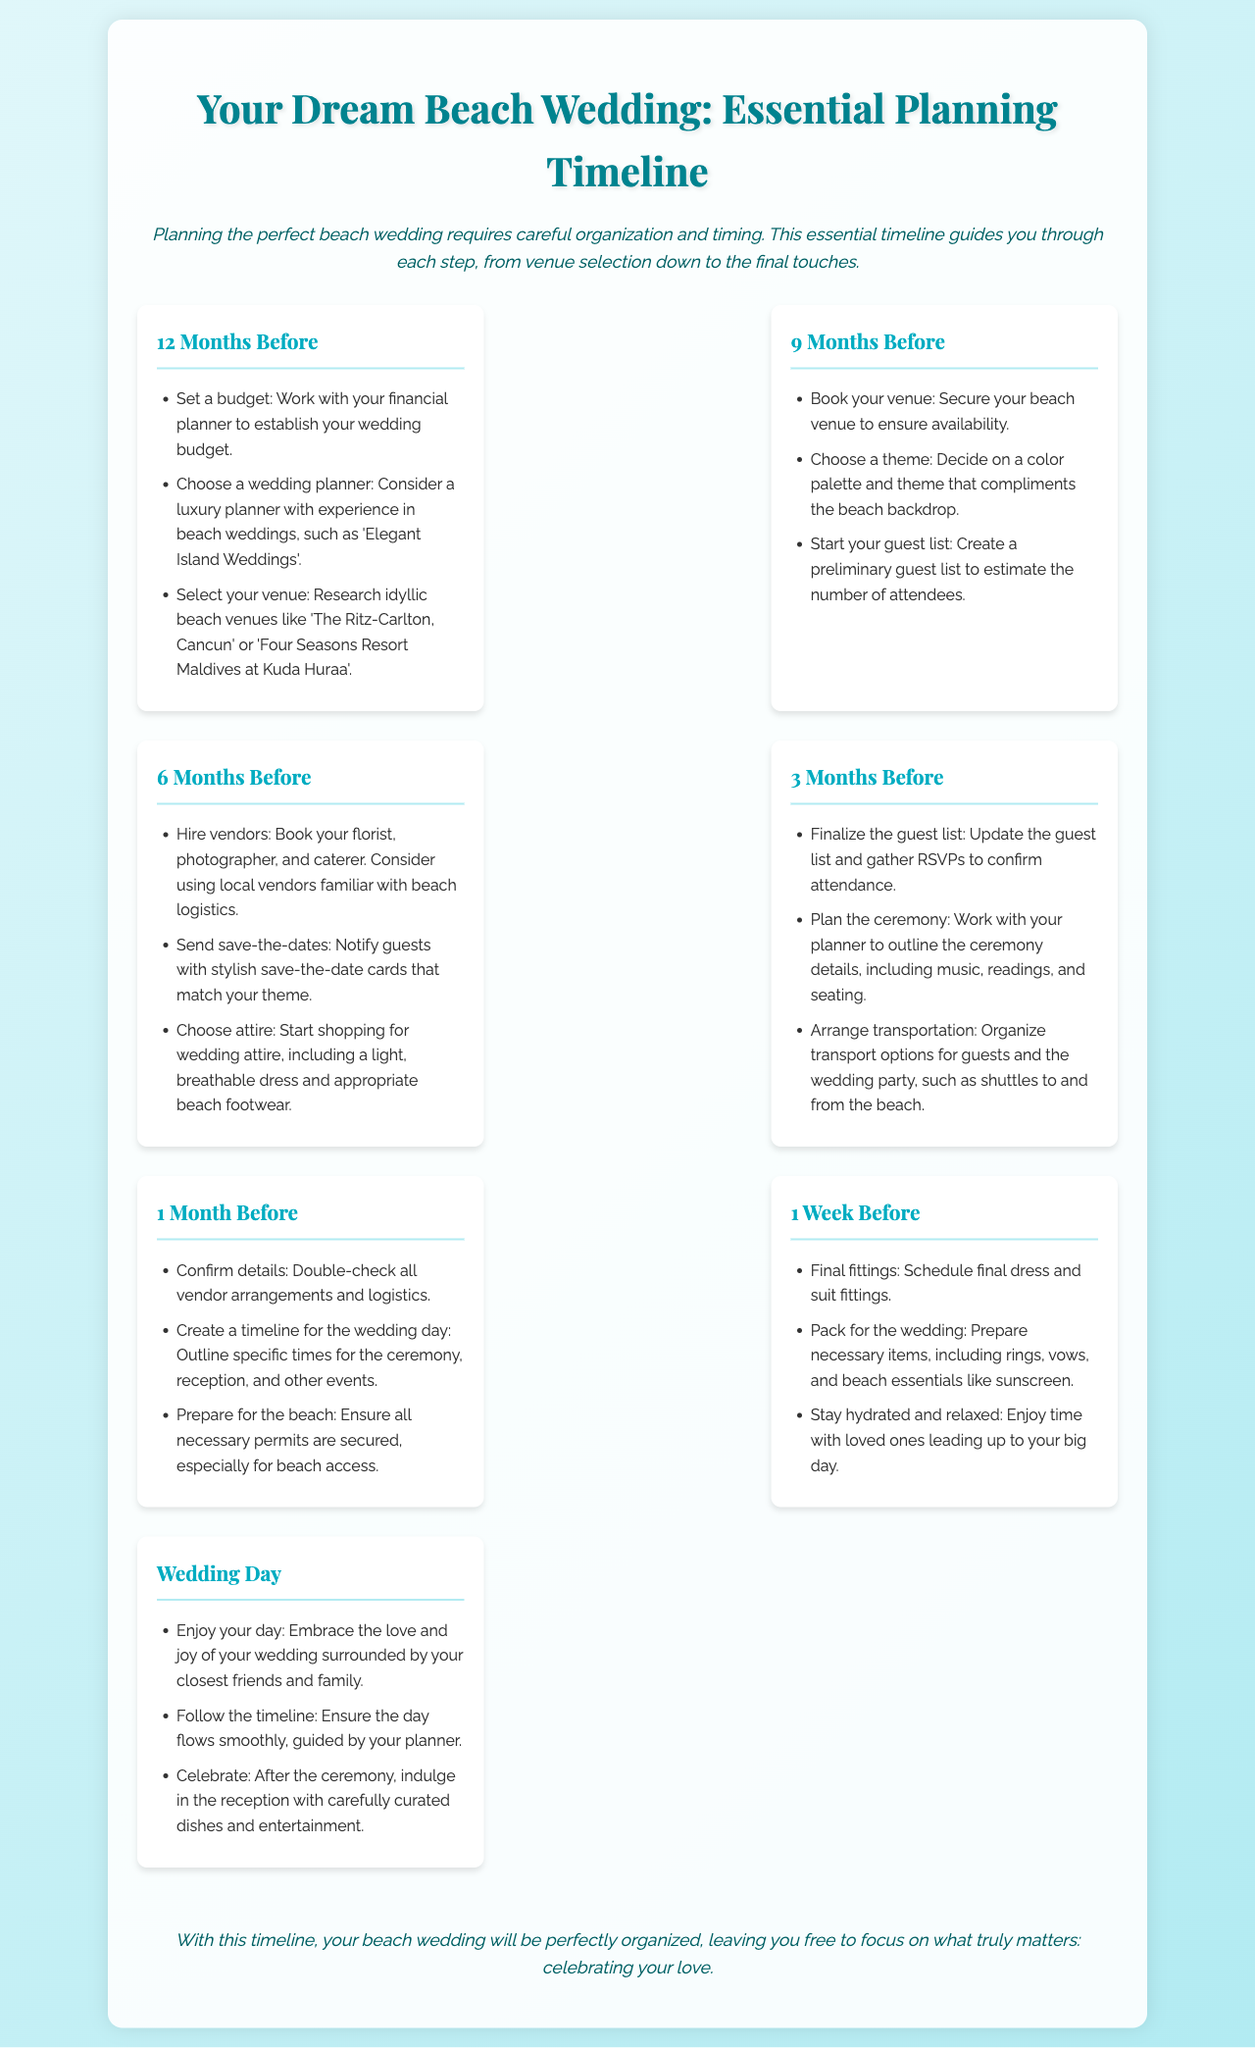What is the title of the document? The title is provided as the main heading of the document, which summarizes its purpose.
Answer: Your Dream Beach Wedding: Essential Planning Timeline How many months before the wedding should you select the venue? The document provides a specific timeline for each step, mentioning the action for 12 months before the wedding.
Answer: 12 Months Which vendor type should be booked 6 months before? The timeline item lists the types of vendors to be hired at the 6-month mark, emphasizing essential services.
Answer: Florist, photographer, and caterer What is suggested to prepare one week before the wedding? The document outlines necessary actions in the final week prior to the wedding, including essential preparations.
Answer: Pack for the wedding What should be done the day before the wedding? The wedding day is described with key actions to focus on for a joyful celebration.
Answer: Enjoy your day What color scheme should complement the beach? The timeline emphasizes the importance of a theme that fits the beach environment, particularly in the conceptual stage.
Answer: Color palette Who should be contacted to help with planning? The document specifies the type of professional to consider when needing assistance for beach weddings.
Answer: Luxury planner How many items are listed for the 1 month before tasks? A direct count is needed from the timeline to determine how many tasks must be accomplished during this time.
Answer: 3 items What is the purpose of the document? The document's main goal is stated at the beginning, providing clarity on its use.
Answer: Ensure a seamless planning process 